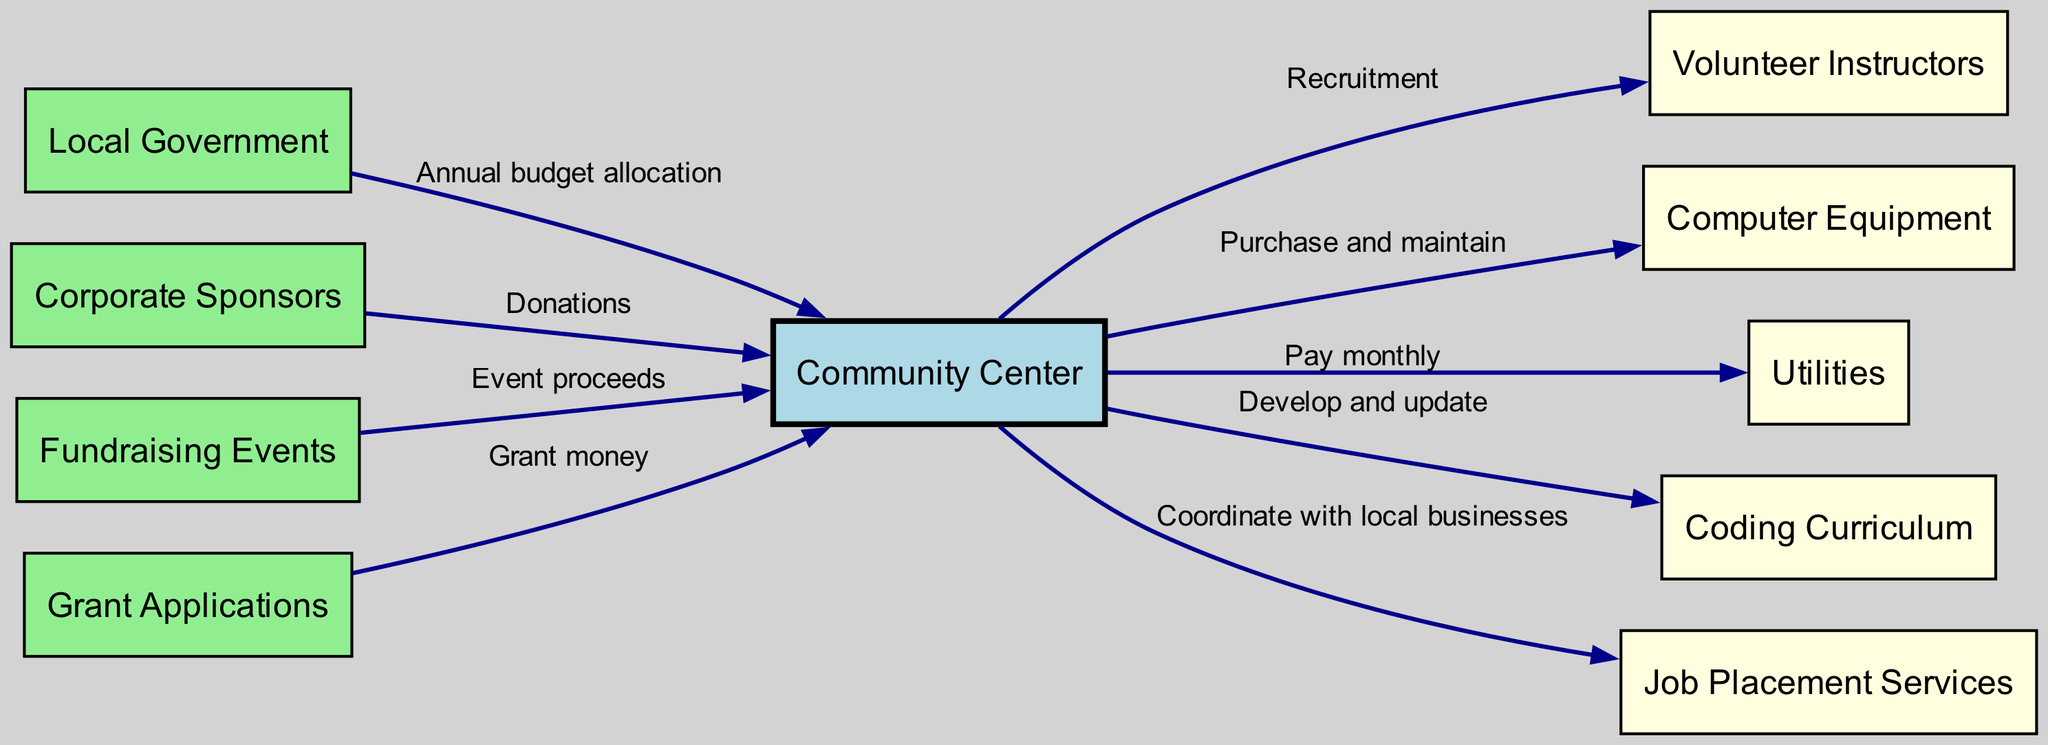What are the sources of funding for the Community Center? The diagram lists four sources of funding: Local Government, Corporate Sponsors, Fundraising Events, and Grant Applications. Each of these nodes is directly connected to the Community Center, indicating their role in providing financial resources.
Answer: Local Government, Corporate Sponsors, Fundraising Events, Grant Applications How many nodes are in the diagram? The diagram contains nine nodes. Counting each one listed in the data under "nodes," we have Community Center, Local Government, Corporate Sponsors, Fundraising Events, Grant Applications, Volunteer Instructors, Computer Equipment, Utilities, Coding Curriculum, and Job Placement Services.
Answer: Nine Which node receives the proceeds from fundraising events? According to the diagram, proceeds from Fundraising Events are directed to the Community Center, as indicated by the edge labeled "Event proceeds."
Answer: Community Center What is the relationship between the Community Center and Volunteer Instructors? The diagram shows that the Community Center recruits Volunteer Instructors. This is denoted by the directed edge labeled "Recruitment" from the Community Center to the Volunteer Instructors.
Answer: Recruitment How does the Community Center receive grant money? The diagram illustrates that the Community Center applies for grants. The edge labeled "Grant money" signifies that the Grants Applications node is connected to the Community Center, indicating the flow of funding.
Answer: Grant Applications Who is responsible for developing and updating the coding curriculum? The connection in the diagram specifies that the Community Center is responsible for developing and updating the Coding Curriculum, as shown by the directed edge from the Community Center to the Coding Curriculum.
Answer: Community Center Which two nodes are responsible for supplying the Community Center with essential resources? The diagram indicates that Computer Equipment and Utilities are provided to the Community Center. The edges labeled "Purchase and maintain" and "Pay monthly" demonstrate these relationships.
Answer: Computer Equipment, Utilities What type of services does the Community Center coordinate with local businesses? The diagram shows that the Community Center coordinates Job Placement Services, as indicated by the directed edge labeled "Coordinate with local businesses" leading to Job Placement Services.
Answer: Job Placement Services Which node represents annual budget allocation? The Local Government node represents the annual budget allocation for the Community Center, as depicted by the edge labeled "Annual budget allocation" directed from the Local Government to the Community Center.
Answer: Local Government 